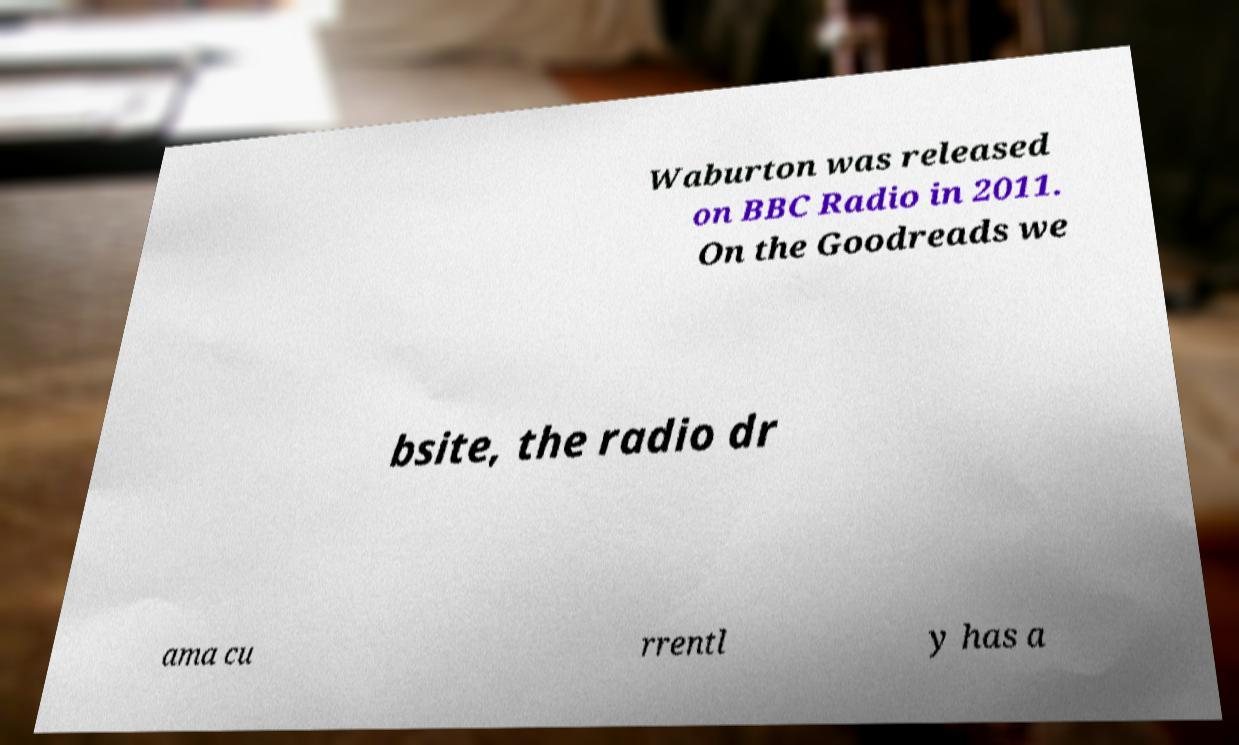Please read and relay the text visible in this image. What does it say? Waburton was released on BBC Radio in 2011. On the Goodreads we bsite, the radio dr ama cu rrentl y has a 